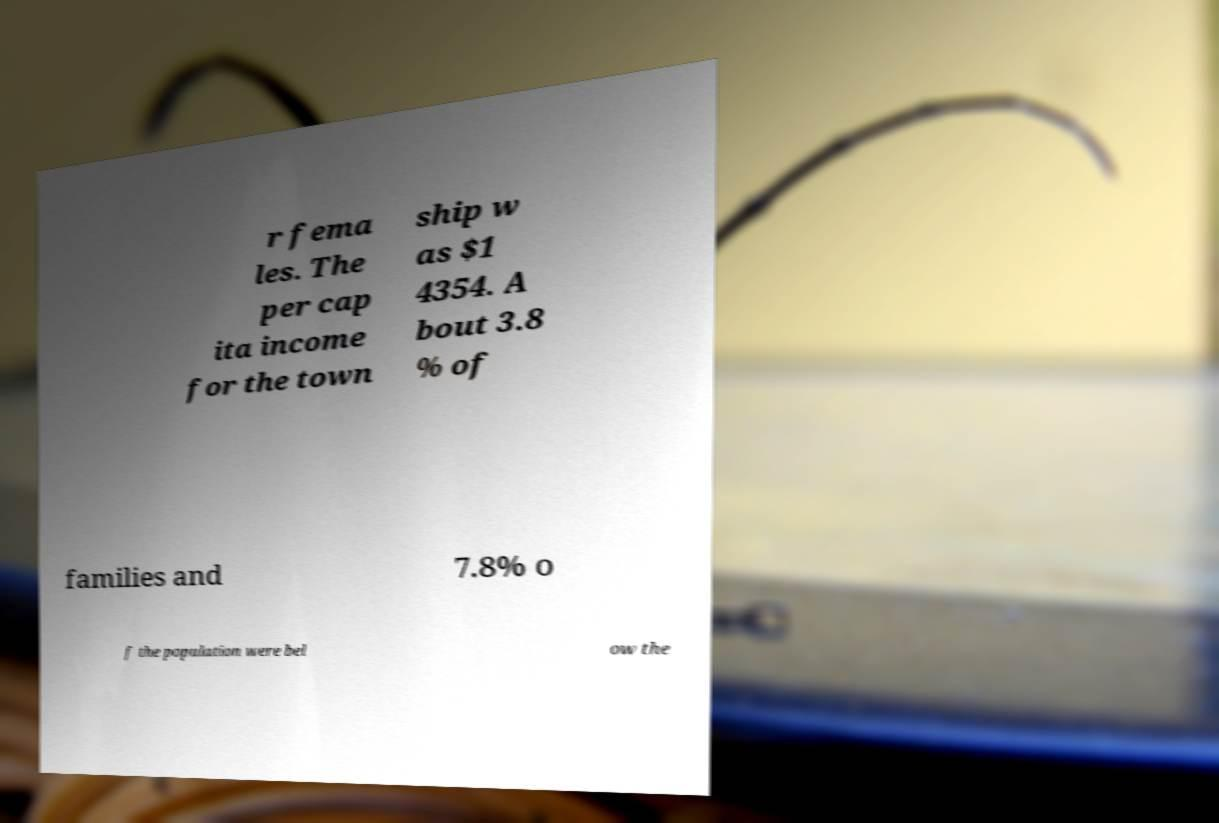Can you accurately transcribe the text from the provided image for me? r fema les. The per cap ita income for the town ship w as $1 4354. A bout 3.8 % of families and 7.8% o f the population were bel ow the 